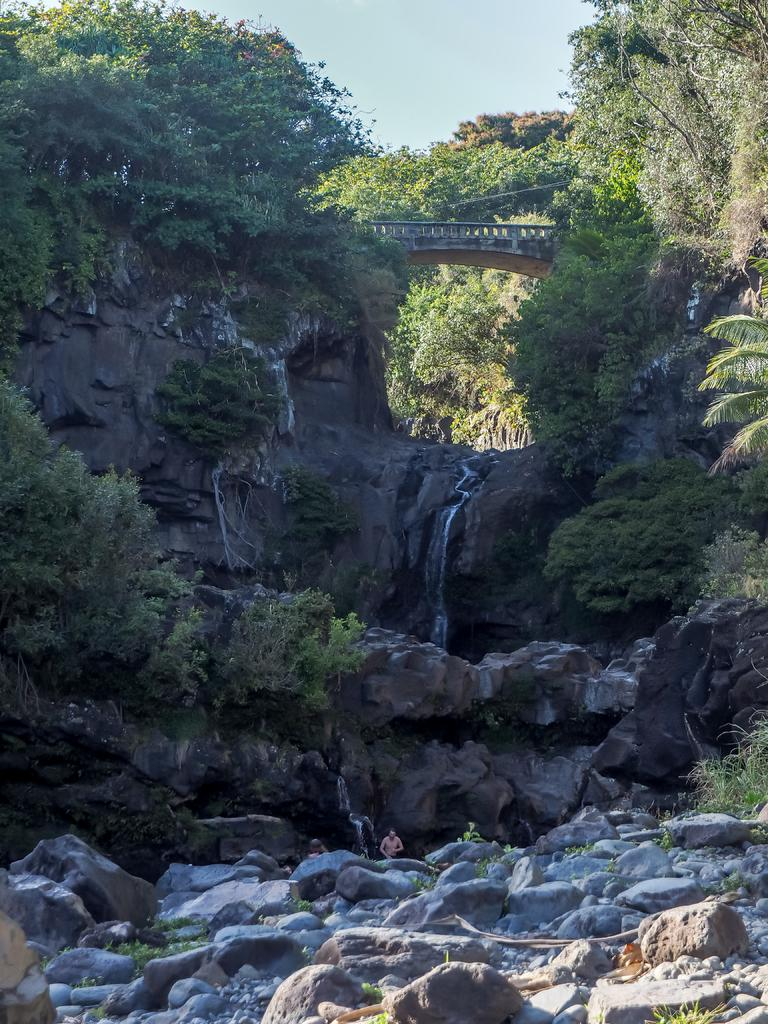What type of environment is shown in the image? The image depicts a forest area. What geological features can be seen in the image? There are rocks and a rock hill in the image. Are there any plants growing on the rock hill? Yes, there are plants in the rock hill. What is visible at the top of the rock hill? The top of the rock hill has rocks. What part of the natural environment can be seen in the image? The sky is visible in the image. What type of meat is being cooked on the grill in the image? There is no grill or meat present in the image; it depicts a forest area with rocks and a rock hill. 